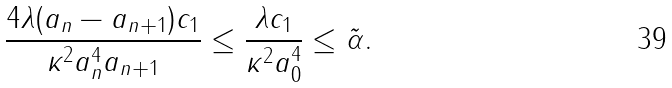<formula> <loc_0><loc_0><loc_500><loc_500>\frac { 4 \lambda ( a _ { n } - a _ { n + 1 } ) c _ { 1 } } { \kappa ^ { 2 } a _ { n } ^ { 4 } a _ { n + 1 } } \leq \frac { \lambda c _ { 1 } } { \kappa ^ { 2 } a _ { 0 } ^ { 4 } } \leq \tilde { \alpha } .</formula> 